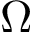Convert formula to latex. <formula><loc_0><loc_0><loc_500><loc_500>\Omega</formula> 